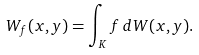Convert formula to latex. <formula><loc_0><loc_0><loc_500><loc_500>W _ { f } ( x , y ) = \int _ { K } f \, d W ( x , y ) .</formula> 